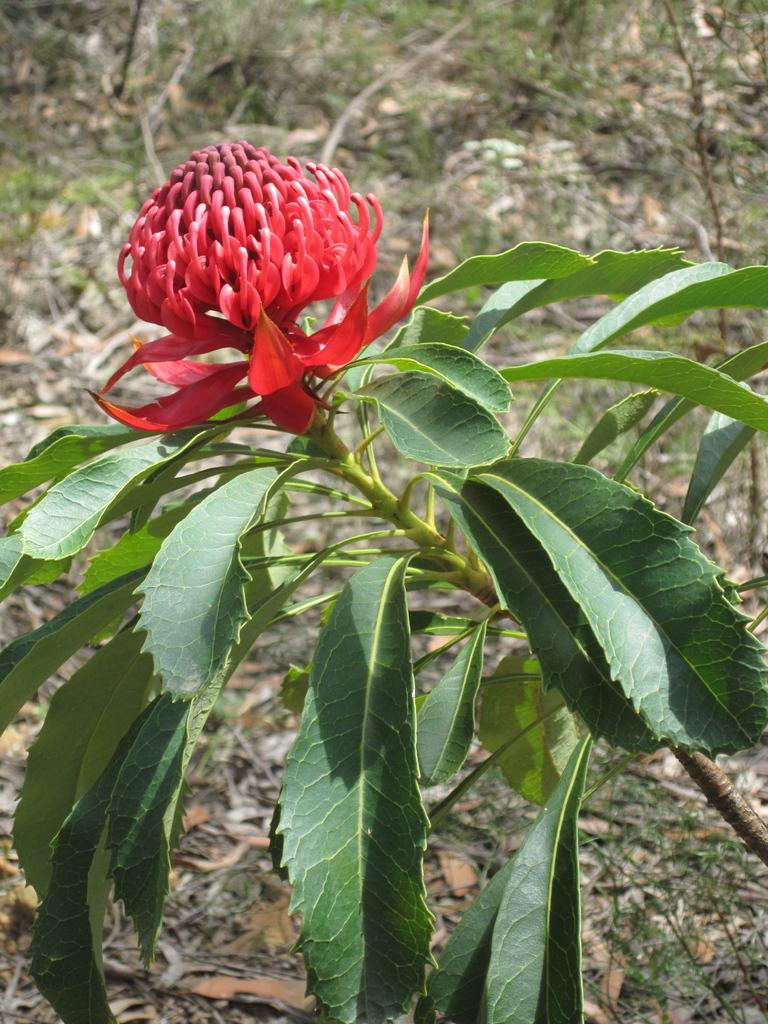What is the main subject of the image? There is a flower plant in the center of the image. What color is the flower on the plant? The flower is red in color. What type of gun is the daughter holding in the image? There is no daughter or gun present in the image; it features a flower plant with a red flower. 